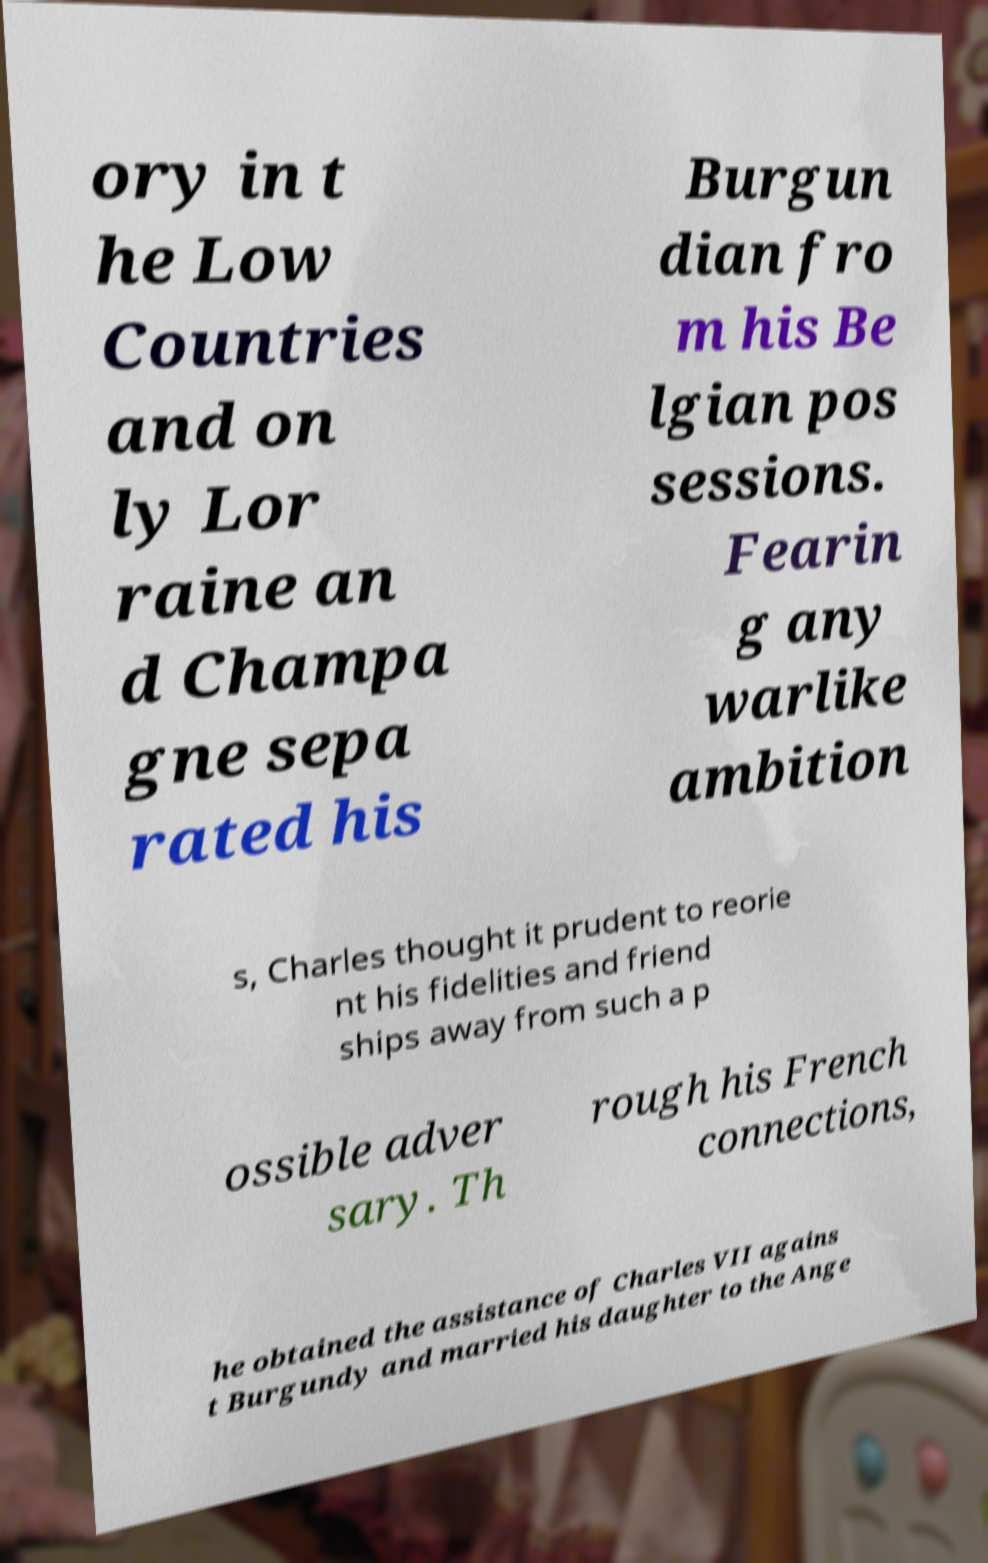Please read and relay the text visible in this image. What does it say? ory in t he Low Countries and on ly Lor raine an d Champa gne sepa rated his Burgun dian fro m his Be lgian pos sessions. Fearin g any warlike ambition s, Charles thought it prudent to reorie nt his fidelities and friend ships away from such a p ossible adver sary. Th rough his French connections, he obtained the assistance of Charles VII agains t Burgundy and married his daughter to the Ange 